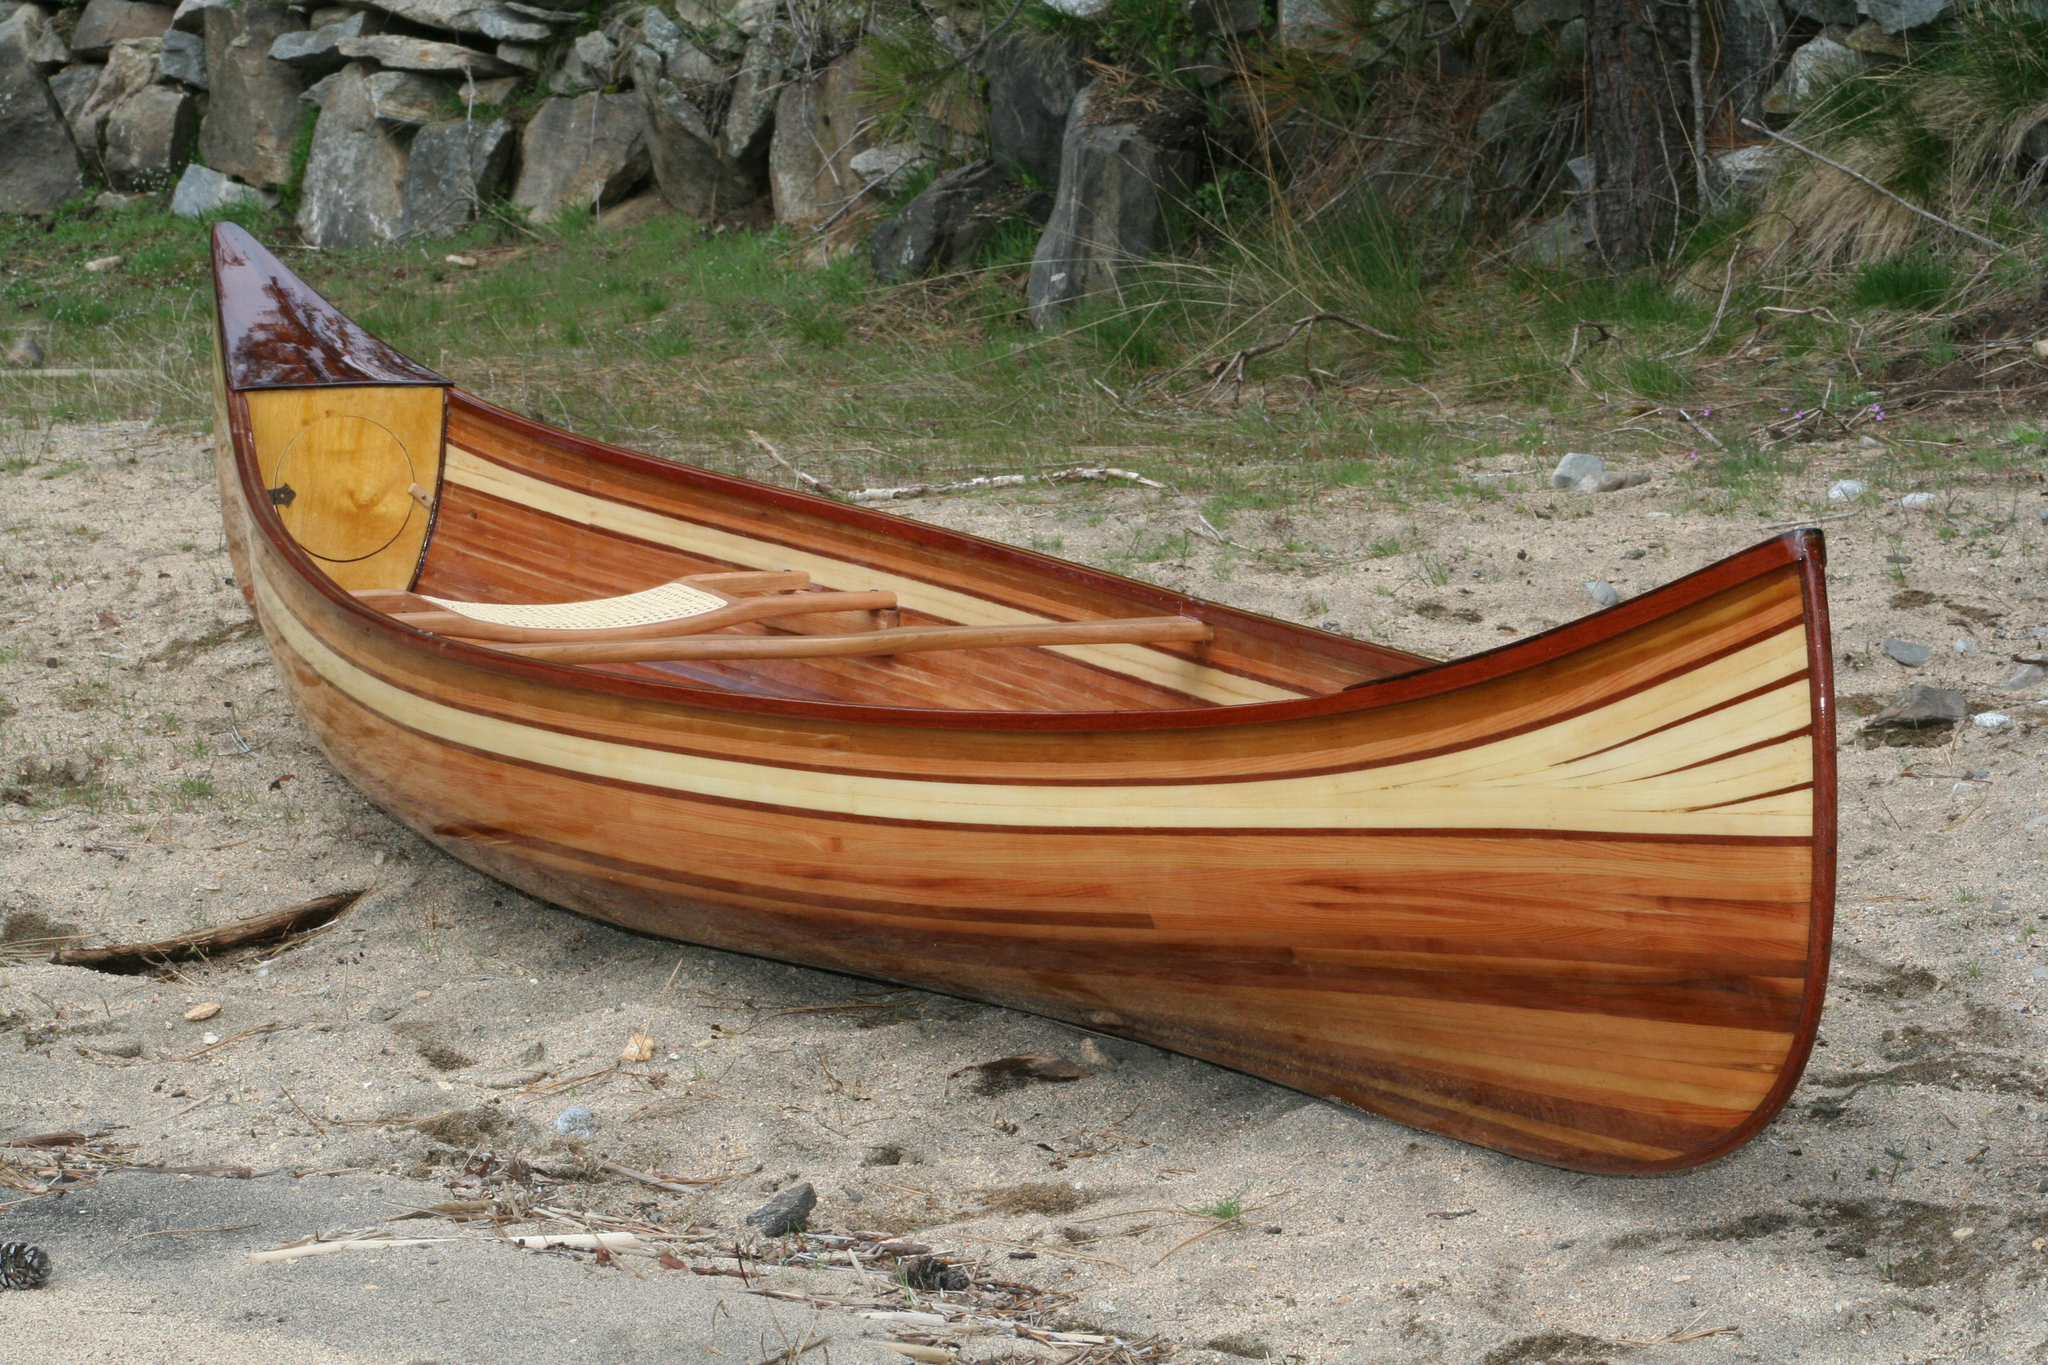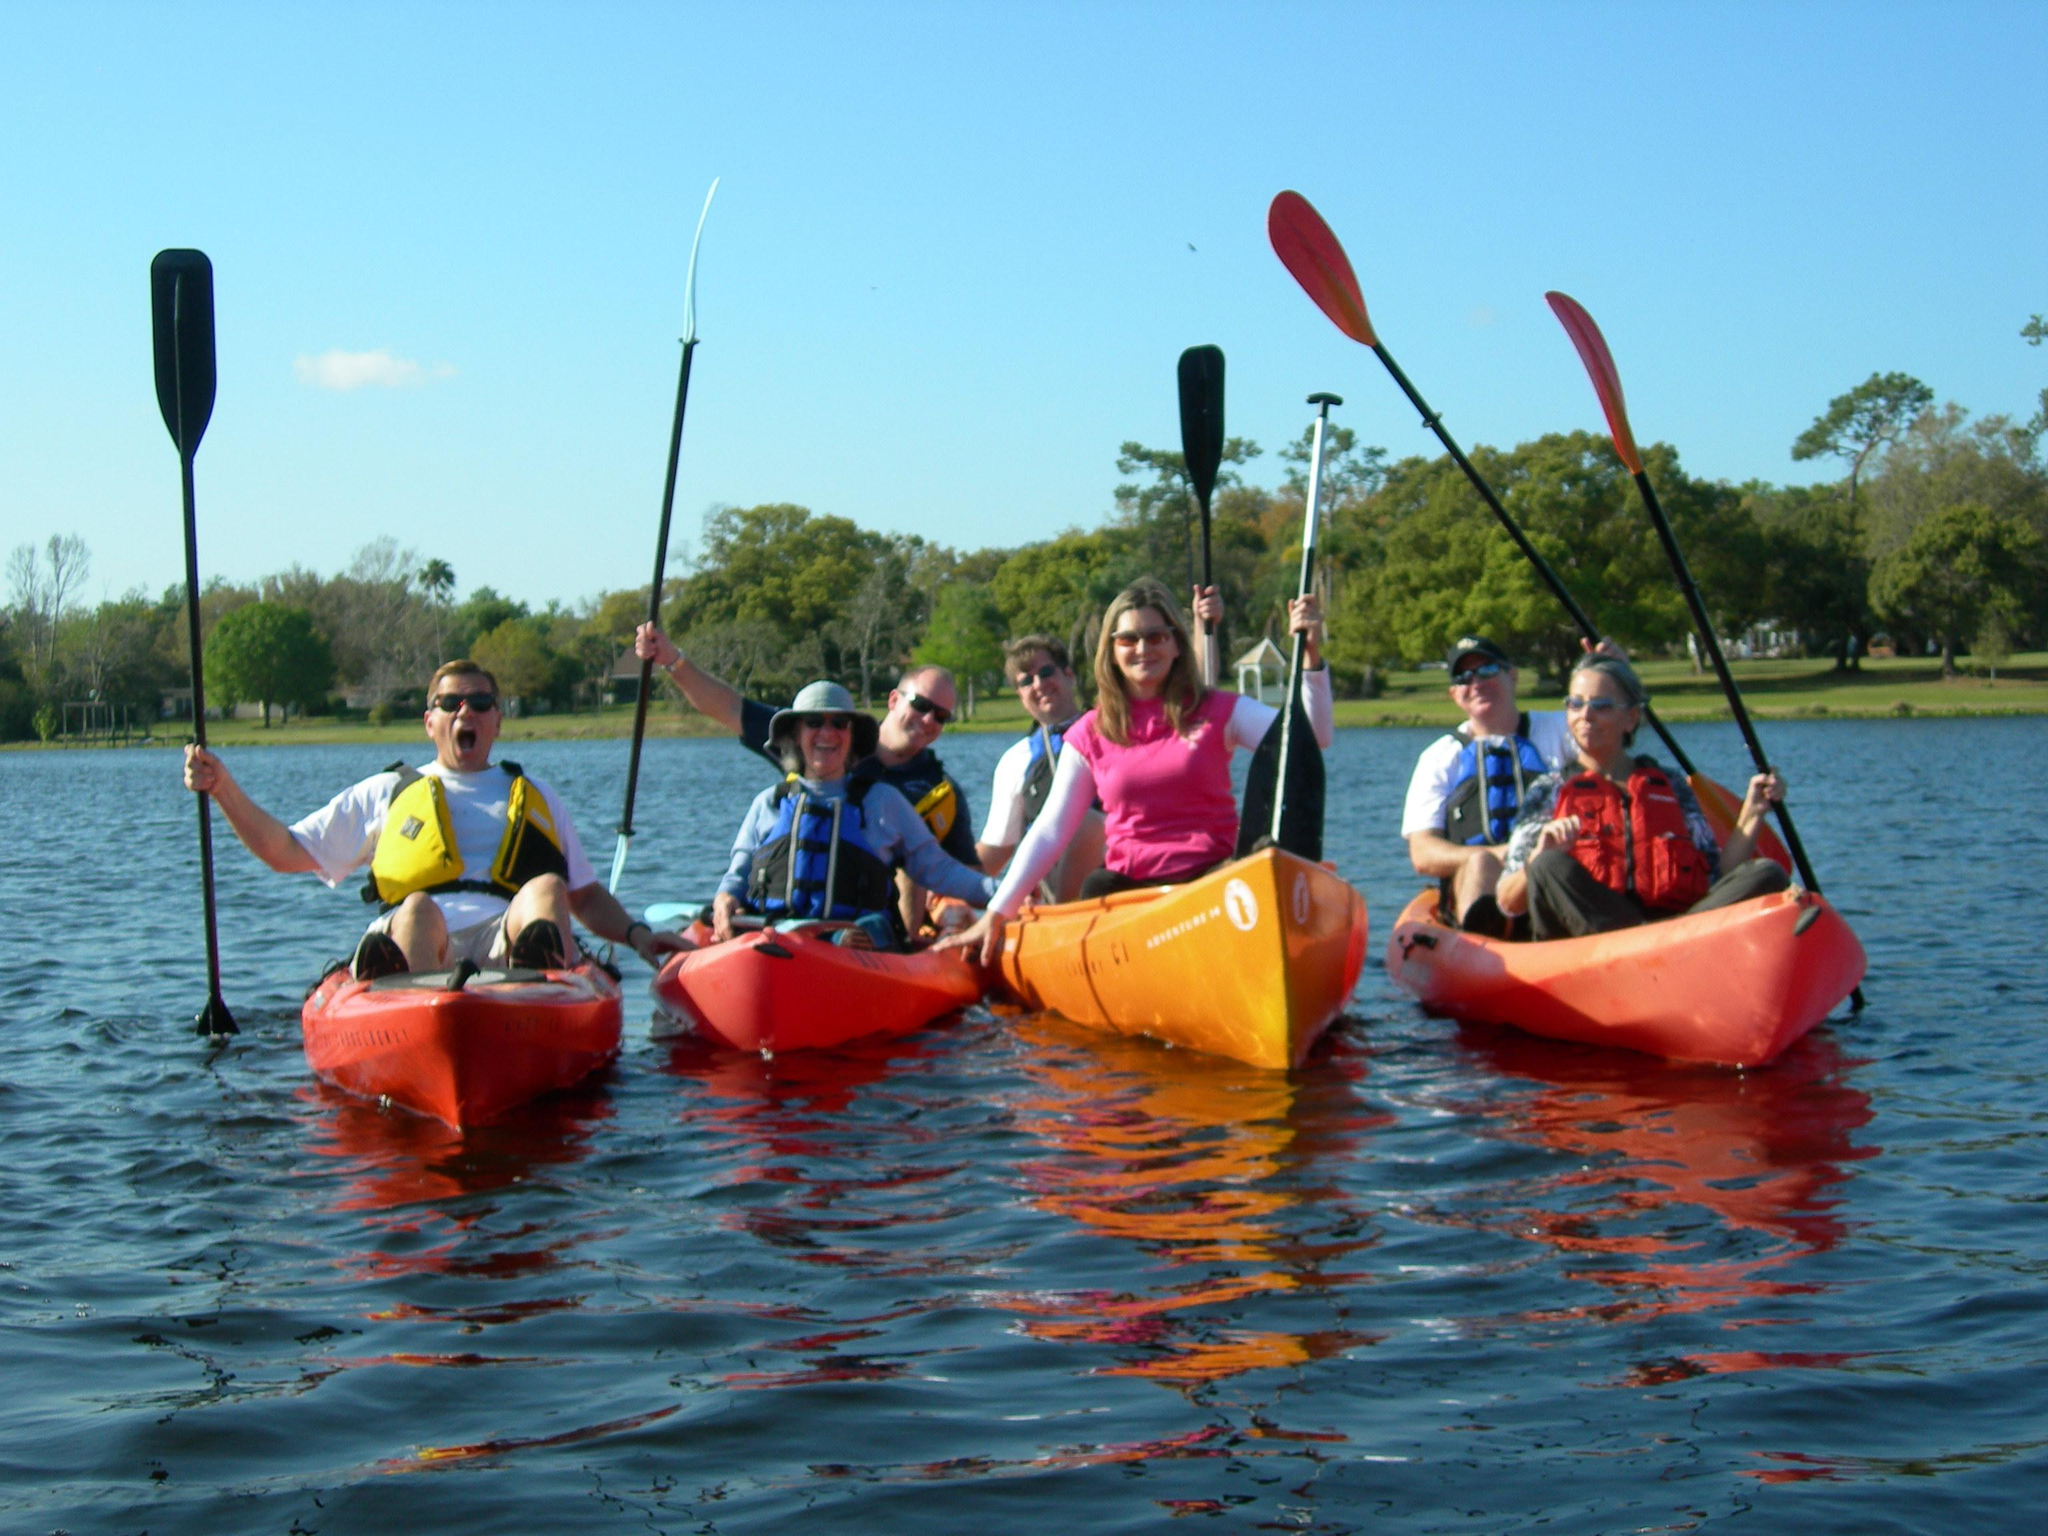The first image is the image on the left, the second image is the image on the right. Given the left and right images, does the statement "Atleast one image has more than one boat" hold true? Answer yes or no. Yes. The first image is the image on the left, the second image is the image on the right. Examine the images to the left and right. Is the description "There are three or less people in boats" accurate? Answer yes or no. No. 